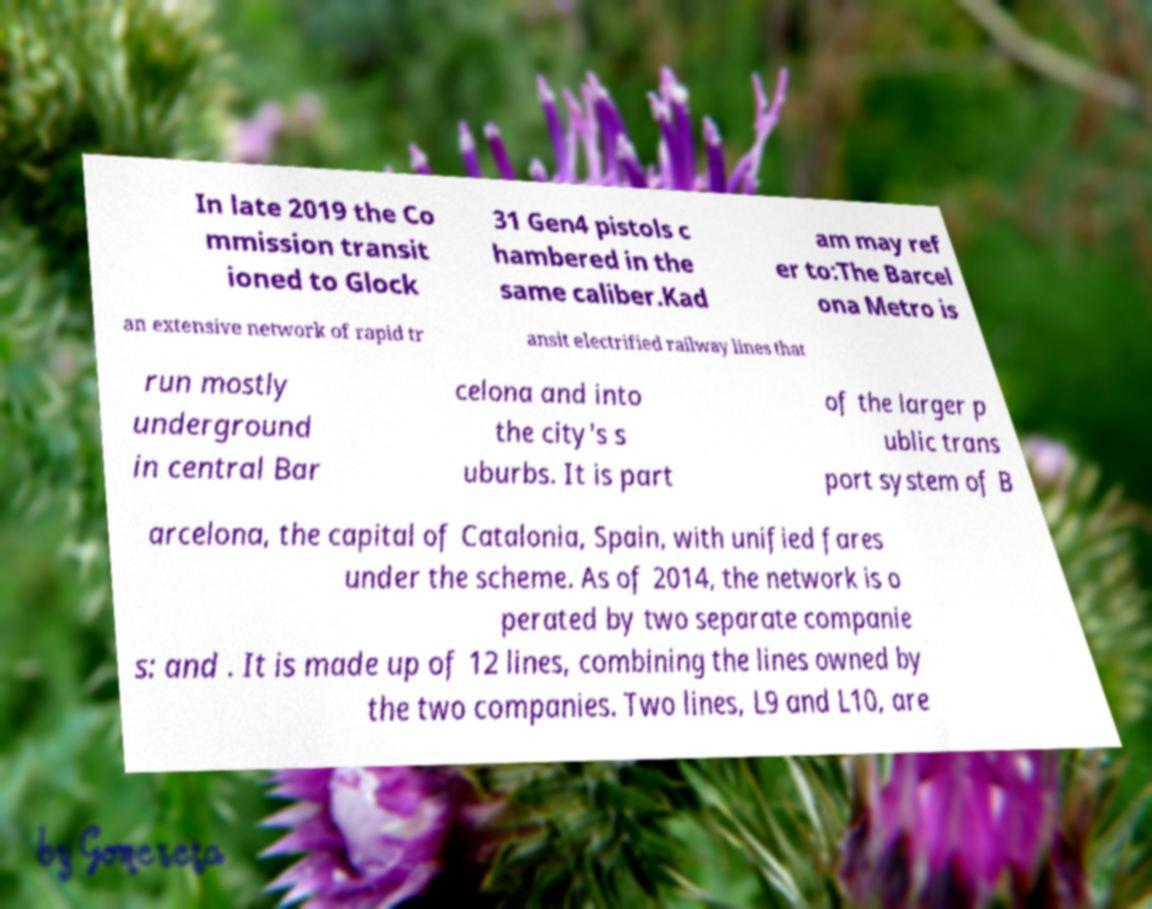For documentation purposes, I need the text within this image transcribed. Could you provide that? In late 2019 the Co mmission transit ioned to Glock 31 Gen4 pistols c hambered in the same caliber.Kad am may ref er to:The Barcel ona Metro is an extensive network of rapid tr ansit electrified railway lines that run mostly underground in central Bar celona and into the city's s uburbs. It is part of the larger p ublic trans port system of B arcelona, the capital of Catalonia, Spain, with unified fares under the scheme. As of 2014, the network is o perated by two separate companie s: and . It is made up of 12 lines, combining the lines owned by the two companies. Two lines, L9 and L10, are 